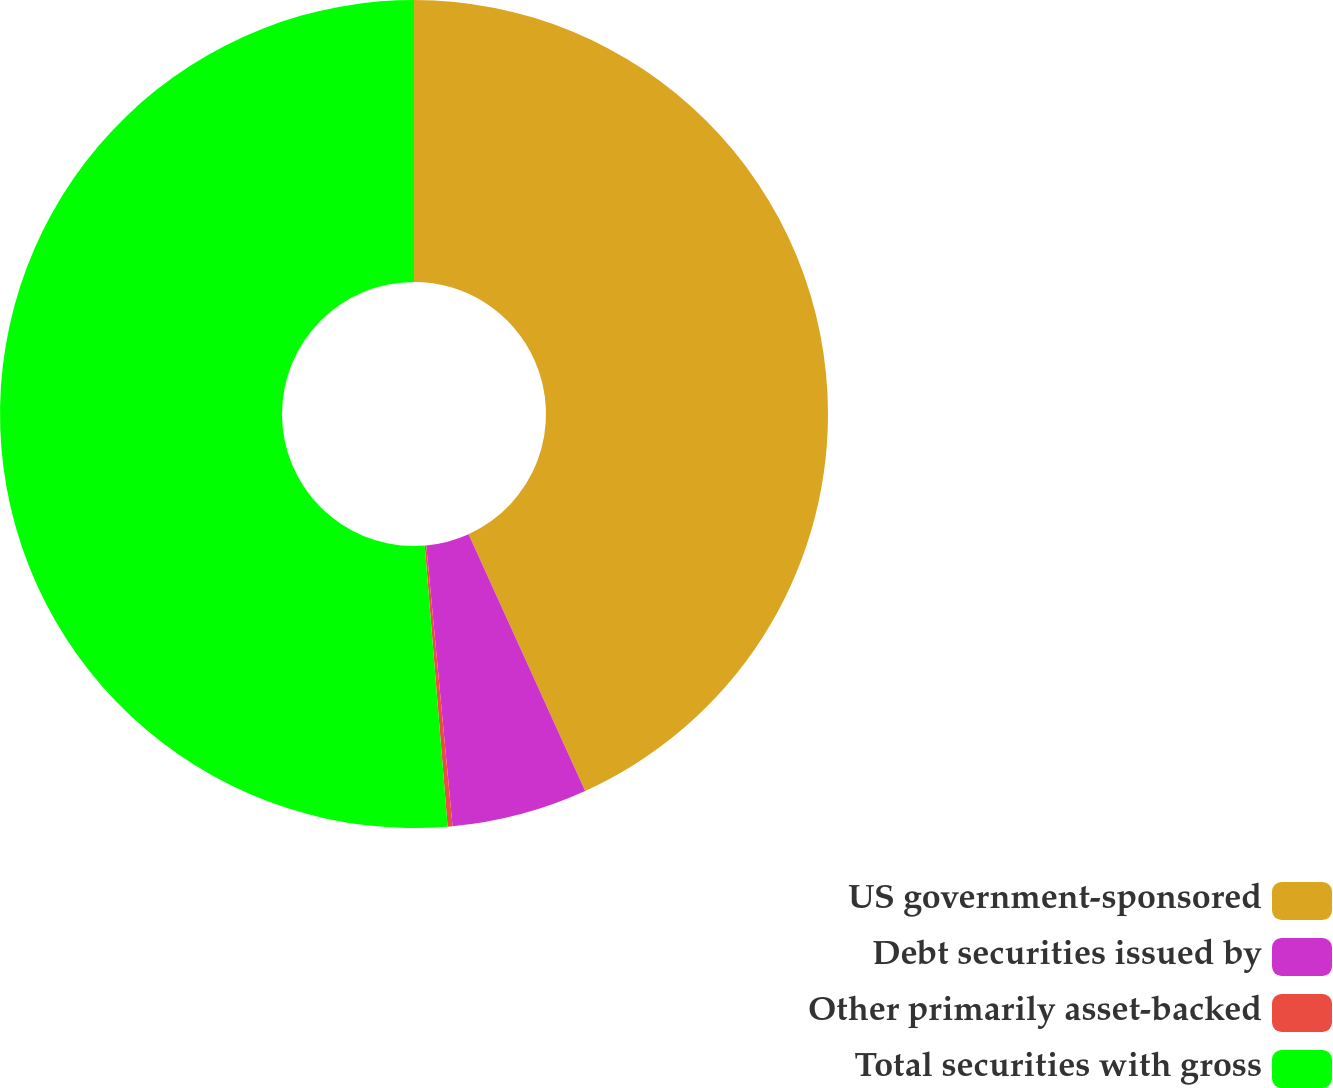Convert chart to OTSL. <chart><loc_0><loc_0><loc_500><loc_500><pie_chart><fcel>US government-sponsored<fcel>Debt securities issued by<fcel>Other primarily asset-backed<fcel>Total securities with gross<nl><fcel>43.22%<fcel>5.3%<fcel>0.19%<fcel>51.3%<nl></chart> 